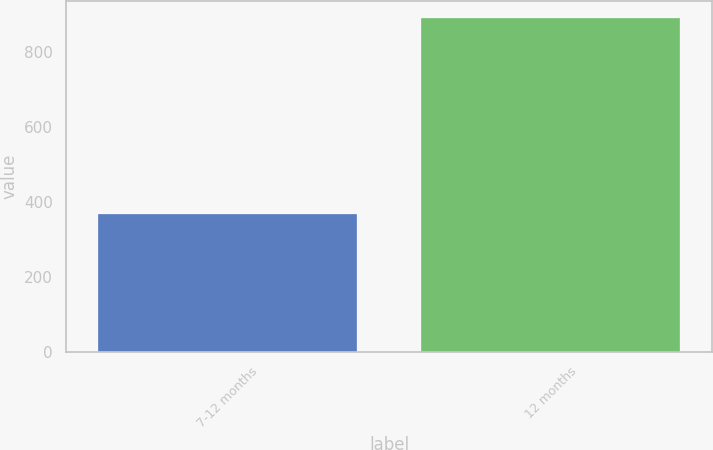Convert chart to OTSL. <chart><loc_0><loc_0><loc_500><loc_500><bar_chart><fcel>7-12 months<fcel>12 months<nl><fcel>368<fcel>889<nl></chart> 